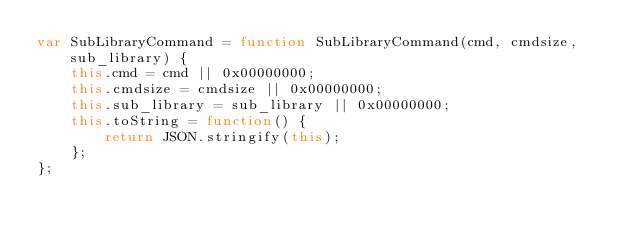Convert code to text. <code><loc_0><loc_0><loc_500><loc_500><_JavaScript_>var SubLibraryCommand = function SubLibraryCommand(cmd, cmdsize, sub_library) {
	this.cmd = cmd || 0x00000000;
	this.cmdsize = cmdsize || 0x00000000;
	this.sub_library = sub_library || 0x00000000;
	this.toString = function() {
		return JSON.stringify(this);
	};
};</code> 